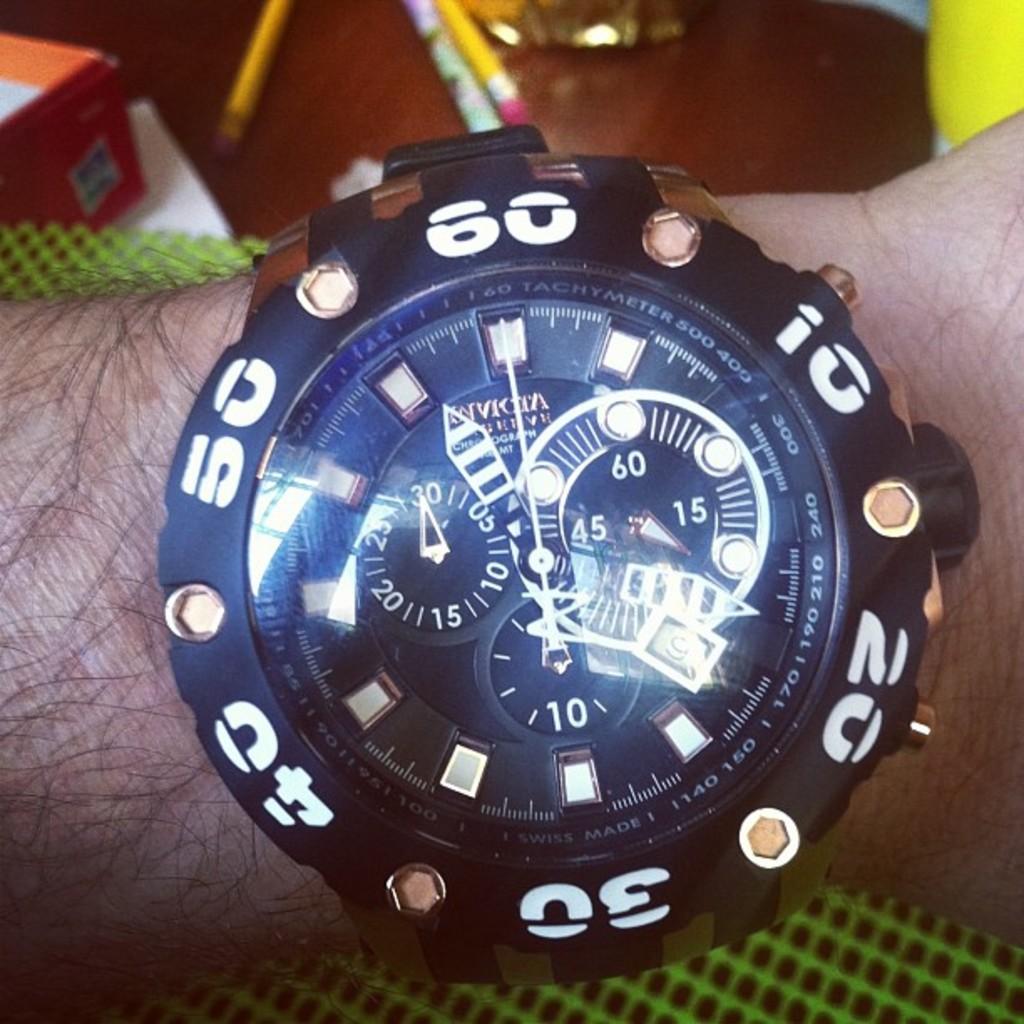What is the highest number on the watch?
Your answer should be compact. 60. What number is the arrow pointing to on the gauge on the left?
Give a very brief answer. 30. 